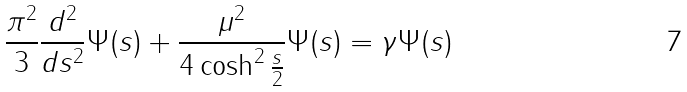<formula> <loc_0><loc_0><loc_500><loc_500>\frac { \pi ^ { 2 } } { 3 } \frac { d ^ { 2 } } { d s ^ { 2 } } \Psi ( s ) + \frac { \mu ^ { 2 } } { 4 \cosh ^ { 2 } \frac { s } { 2 } } \Psi ( s ) = \gamma \Psi ( s )</formula> 